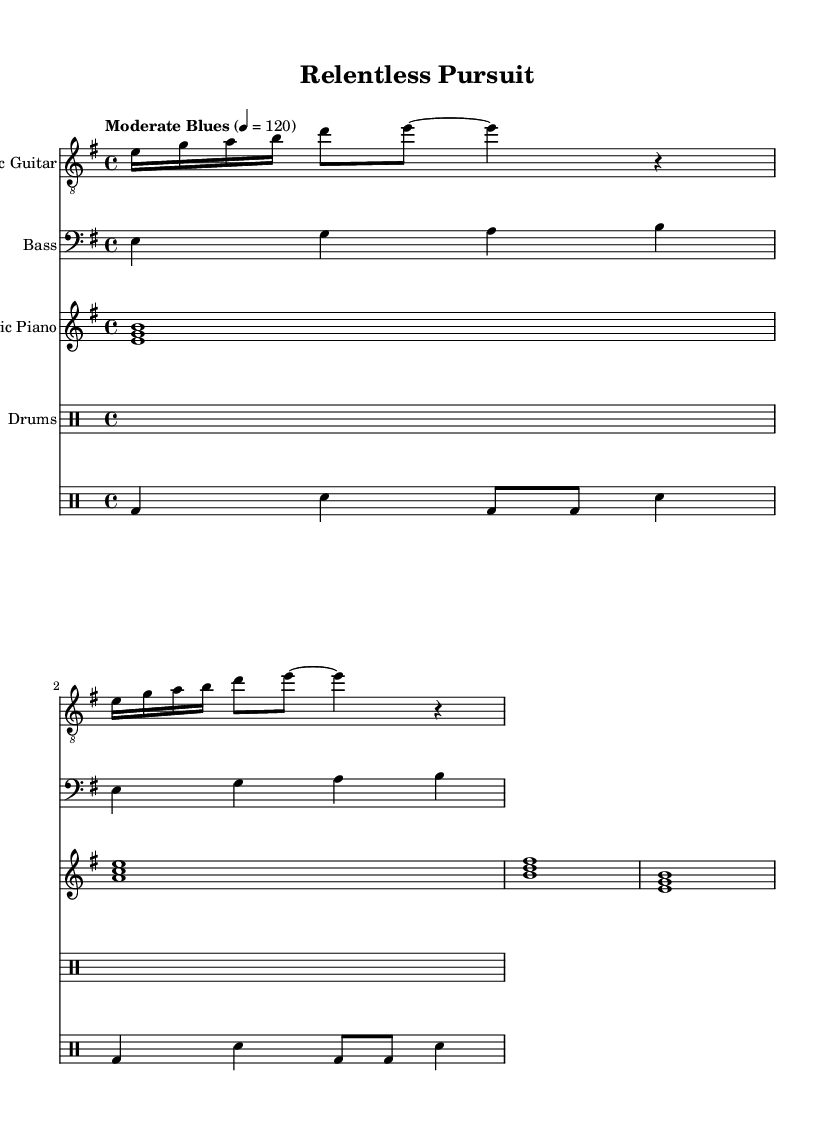What is the key signature of this music? The key signature has one sharp (f#), indicating it is in E minor. Key signatures are typically found at the beginning of the staff.
Answer: E minor What is the time signature of this piece? The time signature is indicated at the beginning of the staff, represented as 4/4. This indicates that there are four beats in a measure and the quarter note gets one beat.
Answer: 4/4 What is the tempo marking for this music? The tempo marking is written in the score and indicates how fast the piece should be played. In this case, it is marked as "Moderate Blues" with a metronome marking of 120, which tells the performer to play at a moderate speed.
Answer: Moderate Blues 120 How many measures are there in the electric guitar part? By counting the measures in the electric guitar part, we can see it contains four measures. Each measure is defined by the vertical lines that separate the notes.
Answer: 4 What type of chord is played in the electric piano during the first measure? The first measure of the electric piano shows the chord formed by the notes E, G, and B played together, which forms an E minor chord. This is identifiable as it consists of the root, minor third, and perfect fifth of the E minor scale.
Answer: E minor What rhythm pattern does the drums follow? The drum part outlines a basic rhythm, with the bass drum (bd) and snare (sn) being played in a sequence: one bass and one snare hit each bar, demonstrating a typical blues feel. This rhythmic structure highlights the essential backbeat characteristic of blues music.
Answer: Basic blues rhythm What is the bass line's note sequence in the second measure? In the second measure of the bass guitar part, the notes are A and B, indicating a progression. This can be determined by looking at the written notes on the staff, which represent specific pitches in the musical scale.
Answer: A, B 